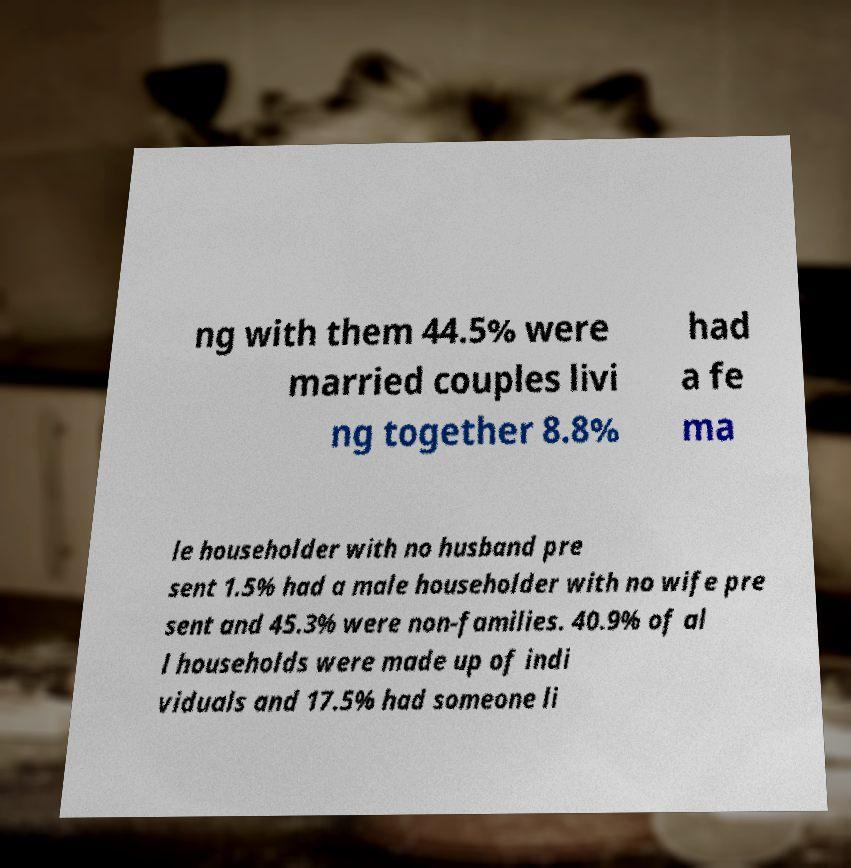Can you read and provide the text displayed in the image?This photo seems to have some interesting text. Can you extract and type it out for me? ng with them 44.5% were married couples livi ng together 8.8% had a fe ma le householder with no husband pre sent 1.5% had a male householder with no wife pre sent and 45.3% were non-families. 40.9% of al l households were made up of indi viduals and 17.5% had someone li 